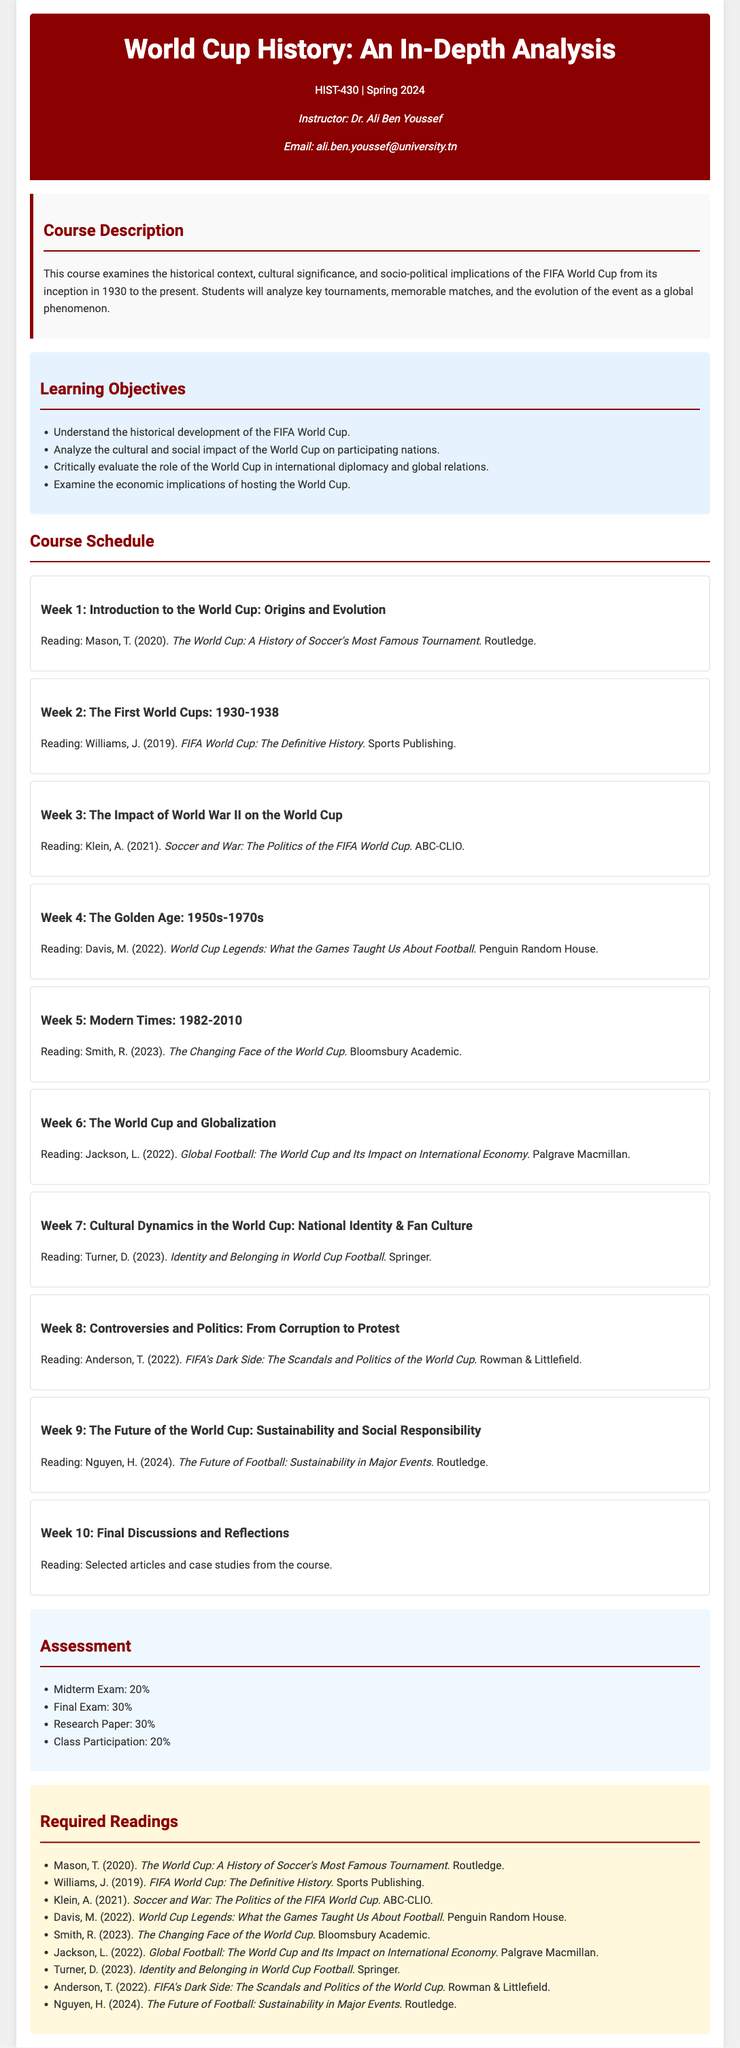What is the course code? The course code is stated in the document, which is HIST-430.
Answer: HIST-430 Who is the instructor for the course? The name of the instructor is mentioned in the document, which is Dr. Ali Ben Youssef.
Answer: Dr. Ali Ben Youssef What is the reading for Week 3? The specific reading assigned for Week 3 is listed in the document, which is Klein, A. (2021). Soccer and War: The Politics of the FIFA World Cup.
Answer: Klein, A. (2021). Soccer and War: The Politics of the FIFA World Cup How many weeks are included in the course schedule? The document outlines ten distinct weeks in the course schedule.
Answer: 10 What percentage of the grade is the research paper worth? The document specifies that the research paper contributes 30% to the overall grade.
Answer: 30% What is the main focus of Week 6? The document details the theme for Week 6, which is "The World Cup and Globalization."
Answer: The World Cup and Globalization List one of the learning objectives. One learning objective is mentioned in the document, which is to understand the historical development of the FIFA World Cup.
Answer: Understand the historical development of the FIFA World Cup What is the reading for the final week of the course? The document indicates that selected articles and case studies from the course will be read in the final week.
Answer: Selected articles and case studies from the course 